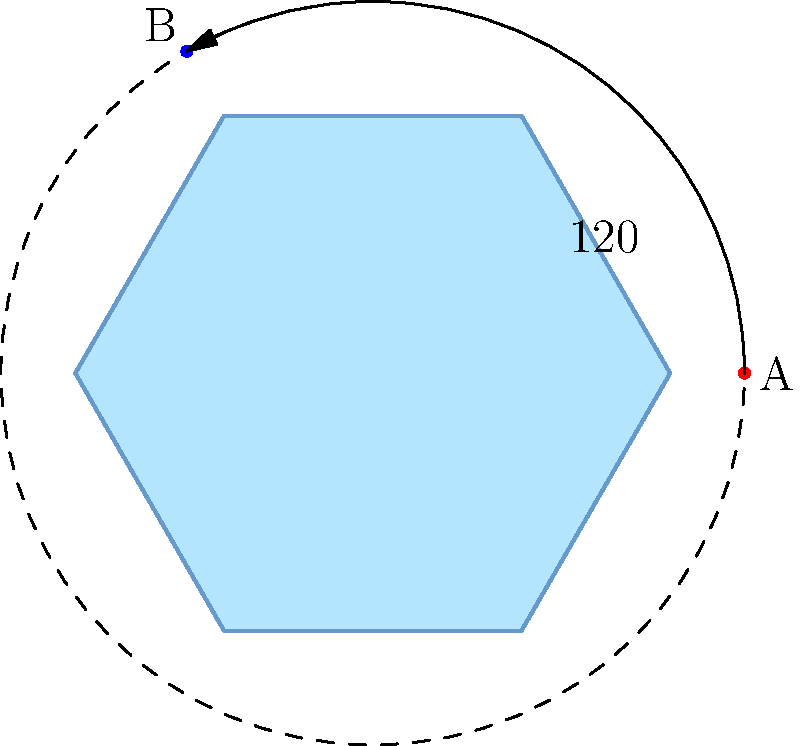In the enchanted chamber, you find a hexagonal crystal that must be rotated to unlock a hidden portal. The crystal is inscribed in a unit circle, with point A initially at (1,0). To reveal the portal, you must rotate the crystal 120° counterclockwise. What are the coordinates of point A after the rotation? To find the coordinates of point A after rotation, we can follow these magical steps:

1) The initial position of A is $(1,0)$ on the unit circle.

2) A rotation by $120°$ counterclockwise is equivalent to a rotation by $\frac{2\pi}{3}$ radians.

3) For a point $(x,y)$ rotated by an angle $\theta$ around the origin, the new coordinates $(x',y')$ are given by:
   $x' = x\cos\theta - y\sin\theta$
   $y' = x\sin\theta + y\cos\theta$

4) In our case, $x=1$, $y=0$, and $\theta = \frac{2\pi}{3}$

5) Substituting these values:
   $x' = 1 \cdot \cos(\frac{2\pi}{3}) - 0 \cdot \sin(\frac{2\pi}{3}) = \cos(\frac{2\pi}{3}) = -\frac{1}{2}$
   $y' = 1 \cdot \sin(\frac{2\pi}{3}) + 0 \cdot \cos(\frac{2\pi}{3}) = \sin(\frac{2\pi}{3}) = \frac{\sqrt{3}}{2}$

6) Therefore, after rotation, point A will be at $(-\frac{1}{2}, \frac{\sqrt{3}}{2})$.

This is the same as point B in the diagram, revealing the location of the hidden portal!
Answer: $(-\frac{1}{2}, \frac{\sqrt{3}}{2})$ 